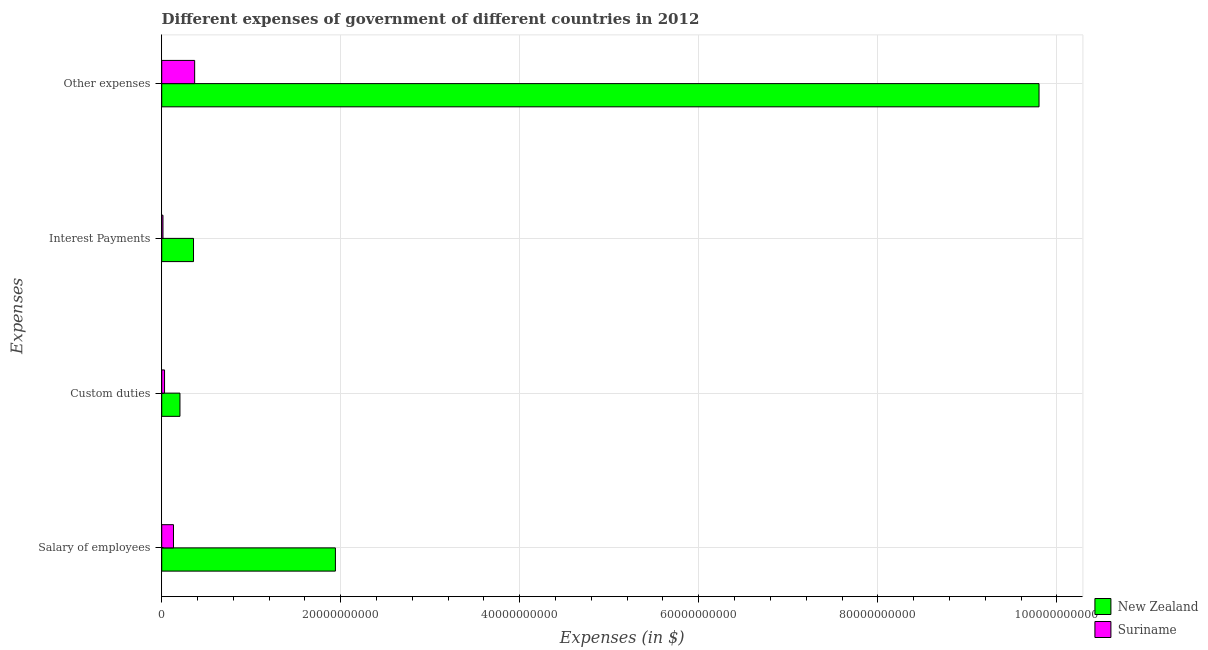How many different coloured bars are there?
Make the answer very short. 2. Are the number of bars per tick equal to the number of legend labels?
Offer a very short reply. Yes. Are the number of bars on each tick of the Y-axis equal?
Your answer should be very brief. Yes. What is the label of the 4th group of bars from the top?
Ensure brevity in your answer.  Salary of employees. What is the amount spent on interest payments in Suriname?
Your answer should be compact. 1.41e+08. Across all countries, what is the maximum amount spent on custom duties?
Your answer should be very brief. 2.04e+09. Across all countries, what is the minimum amount spent on other expenses?
Your answer should be compact. 3.68e+09. In which country was the amount spent on custom duties maximum?
Your answer should be very brief. New Zealand. In which country was the amount spent on interest payments minimum?
Give a very brief answer. Suriname. What is the total amount spent on interest payments in the graph?
Provide a succinct answer. 3.69e+09. What is the difference between the amount spent on custom duties in New Zealand and that in Suriname?
Your answer should be compact. 1.72e+09. What is the difference between the amount spent on other expenses in New Zealand and the amount spent on custom duties in Suriname?
Give a very brief answer. 9.77e+1. What is the average amount spent on interest payments per country?
Your answer should be very brief. 1.85e+09. What is the difference between the amount spent on custom duties and amount spent on interest payments in New Zealand?
Provide a succinct answer. -1.51e+09. What is the ratio of the amount spent on custom duties in New Zealand to that in Suriname?
Give a very brief answer. 6.44. Is the amount spent on other expenses in Suriname less than that in New Zealand?
Offer a terse response. Yes. Is the difference between the amount spent on interest payments in Suriname and New Zealand greater than the difference between the amount spent on custom duties in Suriname and New Zealand?
Provide a short and direct response. No. What is the difference between the highest and the second highest amount spent on other expenses?
Your response must be concise. 9.43e+1. What is the difference between the highest and the lowest amount spent on salary of employees?
Your answer should be compact. 1.81e+1. Is it the case that in every country, the sum of the amount spent on salary of employees and amount spent on custom duties is greater than the sum of amount spent on interest payments and amount spent on other expenses?
Ensure brevity in your answer.  No. What does the 2nd bar from the top in Interest Payments represents?
Give a very brief answer. New Zealand. What does the 2nd bar from the bottom in Interest Payments represents?
Ensure brevity in your answer.  Suriname. Is it the case that in every country, the sum of the amount spent on salary of employees and amount spent on custom duties is greater than the amount spent on interest payments?
Make the answer very short. Yes. How many bars are there?
Provide a short and direct response. 8. How many countries are there in the graph?
Your answer should be compact. 2. Are the values on the major ticks of X-axis written in scientific E-notation?
Provide a short and direct response. No. Does the graph contain any zero values?
Your response must be concise. No. How many legend labels are there?
Give a very brief answer. 2. How are the legend labels stacked?
Make the answer very short. Vertical. What is the title of the graph?
Give a very brief answer. Different expenses of government of different countries in 2012. Does "Malaysia" appear as one of the legend labels in the graph?
Provide a short and direct response. No. What is the label or title of the X-axis?
Your answer should be very brief. Expenses (in $). What is the label or title of the Y-axis?
Ensure brevity in your answer.  Expenses. What is the Expenses (in $) of New Zealand in Salary of employees?
Your answer should be very brief. 1.94e+1. What is the Expenses (in $) in Suriname in Salary of employees?
Your answer should be compact. 1.32e+09. What is the Expenses (in $) in New Zealand in Custom duties?
Your answer should be very brief. 2.04e+09. What is the Expenses (in $) of Suriname in Custom duties?
Ensure brevity in your answer.  3.17e+08. What is the Expenses (in $) in New Zealand in Interest Payments?
Ensure brevity in your answer.  3.55e+09. What is the Expenses (in $) in Suriname in Interest Payments?
Make the answer very short. 1.41e+08. What is the Expenses (in $) of New Zealand in Other expenses?
Offer a very short reply. 9.80e+1. What is the Expenses (in $) in Suriname in Other expenses?
Make the answer very short. 3.68e+09. Across all Expenses, what is the maximum Expenses (in $) in New Zealand?
Give a very brief answer. 9.80e+1. Across all Expenses, what is the maximum Expenses (in $) in Suriname?
Give a very brief answer. 3.68e+09. Across all Expenses, what is the minimum Expenses (in $) of New Zealand?
Make the answer very short. 2.04e+09. Across all Expenses, what is the minimum Expenses (in $) in Suriname?
Offer a terse response. 1.41e+08. What is the total Expenses (in $) of New Zealand in the graph?
Offer a terse response. 1.23e+11. What is the total Expenses (in $) in Suriname in the graph?
Provide a short and direct response. 5.45e+09. What is the difference between the Expenses (in $) of New Zealand in Salary of employees and that in Custom duties?
Make the answer very short. 1.74e+1. What is the difference between the Expenses (in $) in Suriname in Salary of employees and that in Custom duties?
Make the answer very short. 9.99e+08. What is the difference between the Expenses (in $) in New Zealand in Salary of employees and that in Interest Payments?
Your answer should be compact. 1.59e+1. What is the difference between the Expenses (in $) in Suriname in Salary of employees and that in Interest Payments?
Give a very brief answer. 1.18e+09. What is the difference between the Expenses (in $) of New Zealand in Salary of employees and that in Other expenses?
Keep it short and to the point. -7.86e+1. What is the difference between the Expenses (in $) in Suriname in Salary of employees and that in Other expenses?
Provide a succinct answer. -2.37e+09. What is the difference between the Expenses (in $) in New Zealand in Custom duties and that in Interest Payments?
Your answer should be very brief. -1.51e+09. What is the difference between the Expenses (in $) in Suriname in Custom duties and that in Interest Payments?
Ensure brevity in your answer.  1.76e+08. What is the difference between the Expenses (in $) of New Zealand in Custom duties and that in Other expenses?
Provide a succinct answer. -9.60e+1. What is the difference between the Expenses (in $) in Suriname in Custom duties and that in Other expenses?
Keep it short and to the point. -3.36e+09. What is the difference between the Expenses (in $) of New Zealand in Interest Payments and that in Other expenses?
Provide a short and direct response. -9.45e+1. What is the difference between the Expenses (in $) of Suriname in Interest Payments and that in Other expenses?
Your response must be concise. -3.54e+09. What is the difference between the Expenses (in $) in New Zealand in Salary of employees and the Expenses (in $) in Suriname in Custom duties?
Your answer should be compact. 1.91e+1. What is the difference between the Expenses (in $) in New Zealand in Salary of employees and the Expenses (in $) in Suriname in Interest Payments?
Offer a very short reply. 1.93e+1. What is the difference between the Expenses (in $) in New Zealand in Salary of employees and the Expenses (in $) in Suriname in Other expenses?
Provide a short and direct response. 1.57e+1. What is the difference between the Expenses (in $) in New Zealand in Custom duties and the Expenses (in $) in Suriname in Interest Payments?
Ensure brevity in your answer.  1.90e+09. What is the difference between the Expenses (in $) in New Zealand in Custom duties and the Expenses (in $) in Suriname in Other expenses?
Offer a very short reply. -1.64e+09. What is the difference between the Expenses (in $) of New Zealand in Interest Payments and the Expenses (in $) of Suriname in Other expenses?
Offer a very short reply. -1.29e+08. What is the average Expenses (in $) of New Zealand per Expenses?
Give a very brief answer. 3.08e+1. What is the average Expenses (in $) in Suriname per Expenses?
Your answer should be very brief. 1.36e+09. What is the difference between the Expenses (in $) in New Zealand and Expenses (in $) in Suriname in Salary of employees?
Keep it short and to the point. 1.81e+1. What is the difference between the Expenses (in $) in New Zealand and Expenses (in $) in Suriname in Custom duties?
Ensure brevity in your answer.  1.72e+09. What is the difference between the Expenses (in $) in New Zealand and Expenses (in $) in Suriname in Interest Payments?
Give a very brief answer. 3.41e+09. What is the difference between the Expenses (in $) in New Zealand and Expenses (in $) in Suriname in Other expenses?
Give a very brief answer. 9.43e+1. What is the ratio of the Expenses (in $) of New Zealand in Salary of employees to that in Custom duties?
Offer a terse response. 9.52. What is the ratio of the Expenses (in $) of Suriname in Salary of employees to that in Custom duties?
Your answer should be compact. 4.16. What is the ratio of the Expenses (in $) of New Zealand in Salary of employees to that in Interest Payments?
Keep it short and to the point. 5.46. What is the ratio of the Expenses (in $) in Suriname in Salary of employees to that in Interest Payments?
Give a very brief answer. 9.36. What is the ratio of the Expenses (in $) in New Zealand in Salary of employees to that in Other expenses?
Your answer should be very brief. 0.2. What is the ratio of the Expenses (in $) in Suriname in Salary of employees to that in Other expenses?
Your response must be concise. 0.36. What is the ratio of the Expenses (in $) of New Zealand in Custom duties to that in Interest Payments?
Your response must be concise. 0.57. What is the ratio of the Expenses (in $) of Suriname in Custom duties to that in Interest Payments?
Give a very brief answer. 2.25. What is the ratio of the Expenses (in $) of New Zealand in Custom duties to that in Other expenses?
Ensure brevity in your answer.  0.02. What is the ratio of the Expenses (in $) in Suriname in Custom duties to that in Other expenses?
Offer a very short reply. 0.09. What is the ratio of the Expenses (in $) in New Zealand in Interest Payments to that in Other expenses?
Provide a short and direct response. 0.04. What is the ratio of the Expenses (in $) of Suriname in Interest Payments to that in Other expenses?
Ensure brevity in your answer.  0.04. What is the difference between the highest and the second highest Expenses (in $) of New Zealand?
Offer a very short reply. 7.86e+1. What is the difference between the highest and the second highest Expenses (in $) in Suriname?
Your answer should be very brief. 2.37e+09. What is the difference between the highest and the lowest Expenses (in $) of New Zealand?
Offer a very short reply. 9.60e+1. What is the difference between the highest and the lowest Expenses (in $) in Suriname?
Your answer should be very brief. 3.54e+09. 